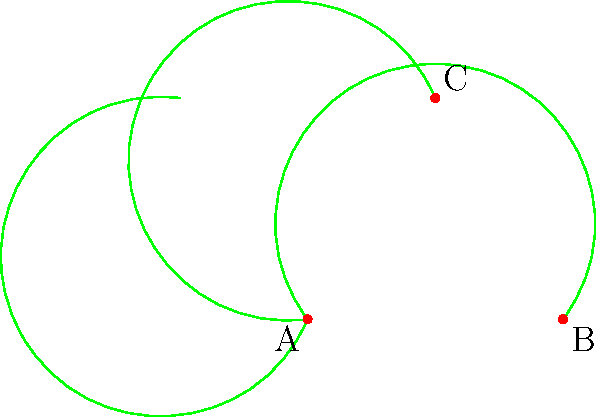In the sheet music border design shown above, three congruent leaf shapes form a repeating pattern. If leaf ABC is rotated 60° clockwise around point A to form leaf ACD, what type of triangle is formed by connecting points A, B, and C? To determine the type of triangle formed by points A, B, and C, let's analyze the given information step-by-step:

1. The leaf shapes are congruent, meaning they have the same size and shape.

2. Leaf ABC is rotated 60° clockwise around point A to form leaf ACD. This implies that:
   a) The angle between AB and AC is 60°.
   b) The length of AB is equal to the length of AC (as they are corresponding sides of congruent shapes).

3. Given that AB = AC and the angle between them is 60°, we can deduce:
   a) Triangle ABC has two equal sides (AB and AC).
   b) One of its angles is 60°.

4. In a triangle with two equal sides (isosceles triangle), the angles opposite these sides are also equal. Therefore, the other two angles in triangle ABC must be equal.

5. The sum of angles in a triangle is always 180°. If one angle is 60°, and the other two are equal, we can calculate each of these angles:
   $$(180° - 60°) ÷ 2 = 60°$$

6. Thus, all three angles in triangle ABC are 60°.

A triangle with all angles measuring 60° is called an equilateral triangle. It not only has all angles equal but also all sides equal.

Therefore, triangle ABC is an equilateral triangle.
Answer: Equilateral triangle 